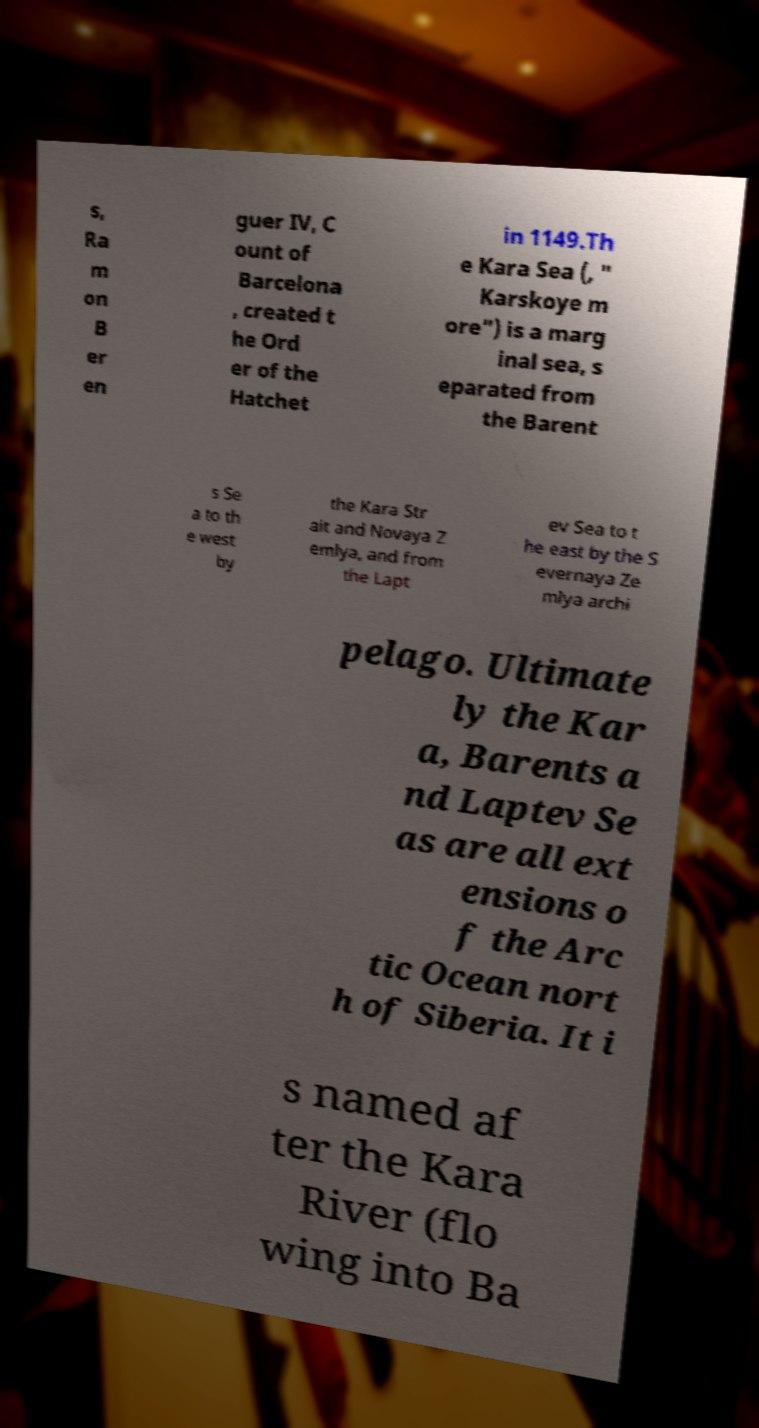Can you accurately transcribe the text from the provided image for me? s, Ra m on B er en guer IV, C ount of Barcelona , created t he Ord er of the Hatchet in 1149.Th e Kara Sea (, " Karskoye m ore") is a marg inal sea, s eparated from the Barent s Se a to th e west by the Kara Str ait and Novaya Z emlya, and from the Lapt ev Sea to t he east by the S evernaya Ze mlya archi pelago. Ultimate ly the Kar a, Barents a nd Laptev Se as are all ext ensions o f the Arc tic Ocean nort h of Siberia. It i s named af ter the Kara River (flo wing into Ba 